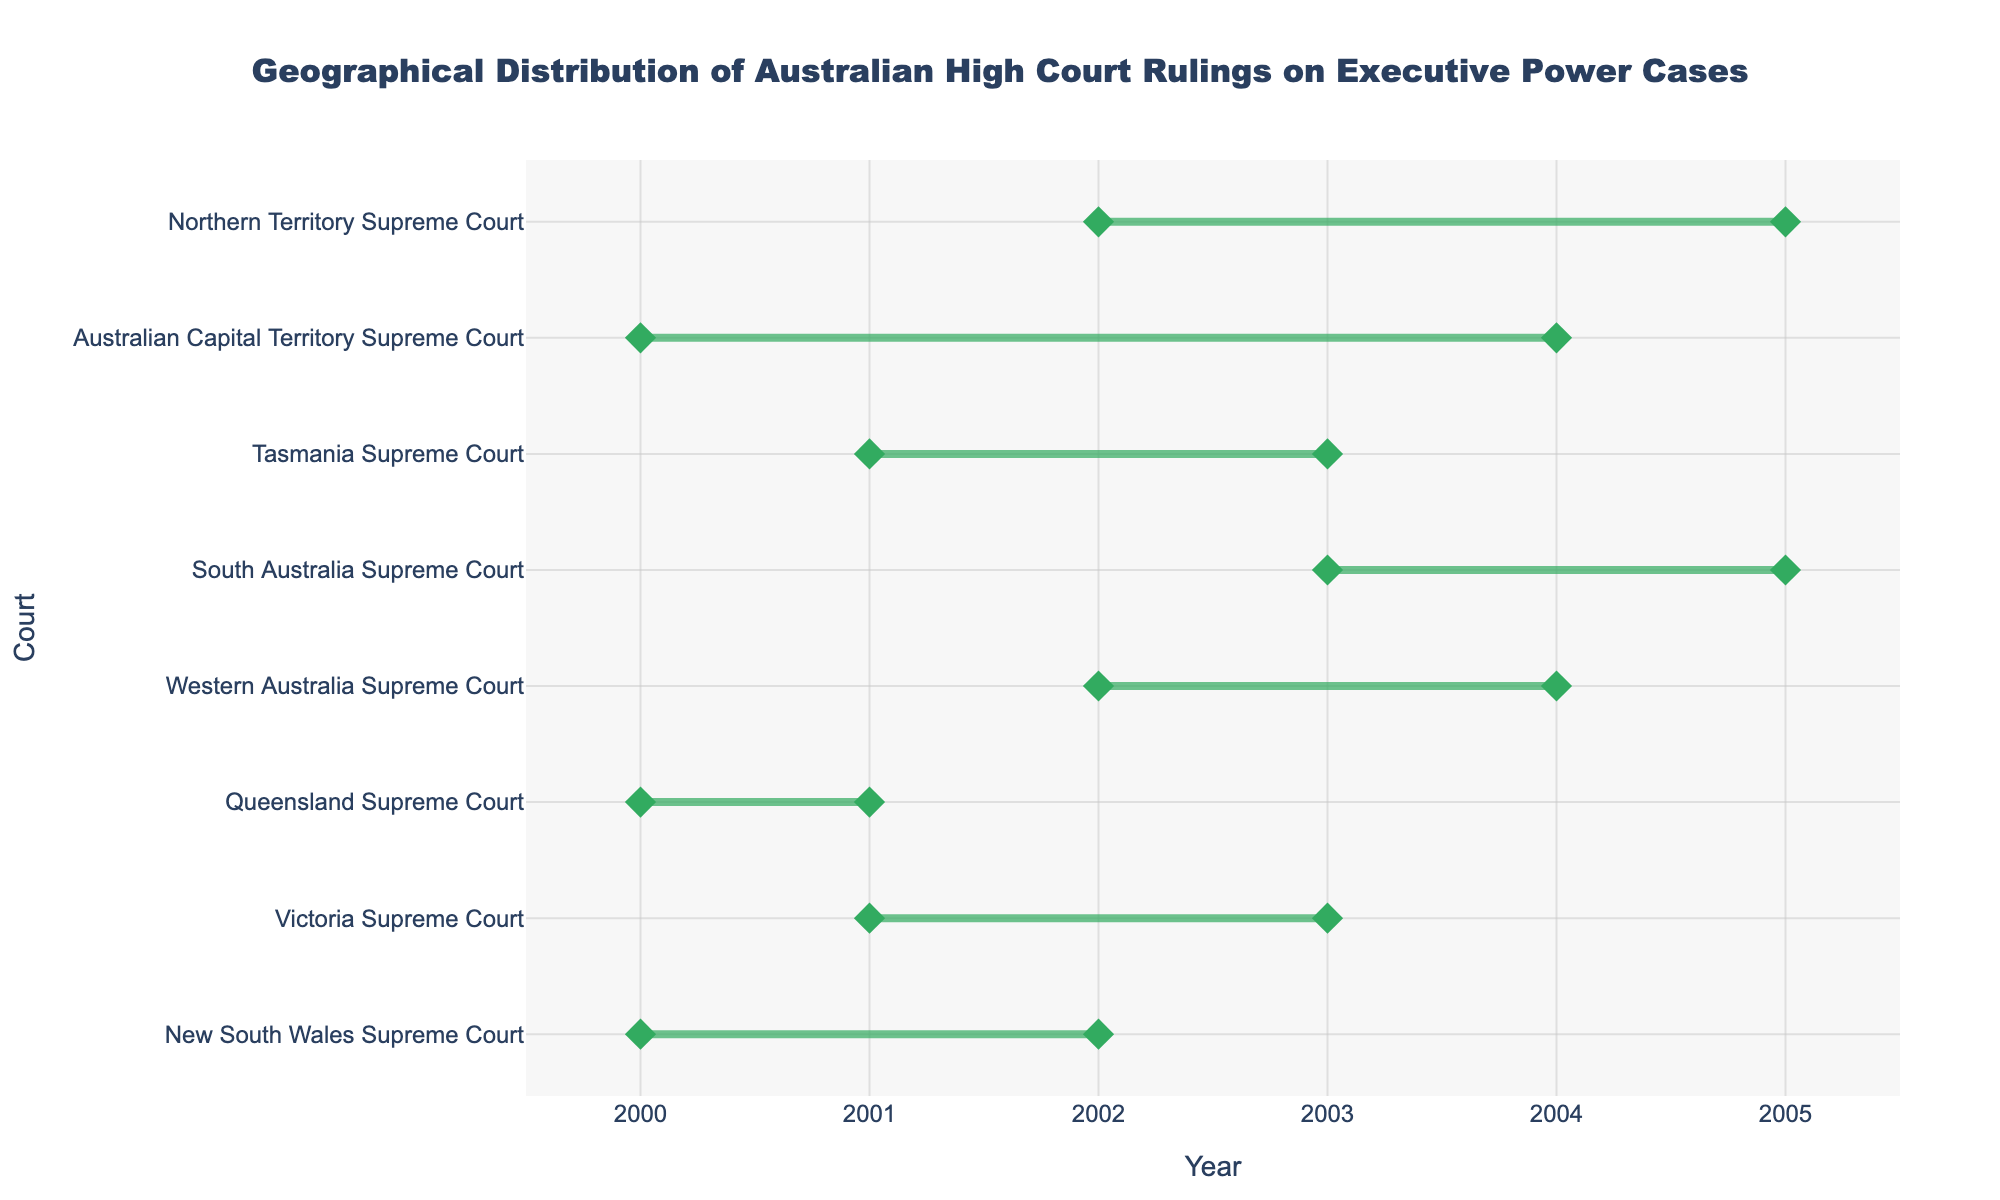What's the title of the plot? The title is usually found at the top of the plot, providing a summary of what the plot represents. The title in this case is "Geographical Distribution of Australian High Court Rulings on Executive Power Cases."
Answer: Geographical Distribution of Australian High Court Rulings on Executive Power Cases Which court has the highest number of rulings? Identify the court with the longest duration in terms of dot markers and observe the text information via hover. The Australian Capital Territory Supreme Court has 8 rulings.
Answer: Australian Capital Territory Supreme Court During which years did the Victoria Supreme Court have rulings on executive power cases? Look at the horizontal line corresponding to the Victoria Supreme Court and read the range on the x-axis. The Victoria Supreme Court rulings span from 2001 to 2003.
Answer: 2001 to 2003 How many rulings were issued by the New South Wales Supreme Court? Find the New South Wales Supreme Court on the y-axis and refer to the text hover information which indicates the number of rulings as 5.
Answer: 5 Which court covered the longest span of years for their cases? Evaluate the length of each line representing the time span of rulings for each court. The Australian Capital Territory Supreme Court covers the longest period, from 2000 to 2004.
Answer: Australian Capital Territory Supreme Court What is the average number of rulings across all courts? Sum the number of rulings for each court (5 + 7 + 4 + 6 + 3 + 2 + 8 + 4) which is 39. There are 8 courts, so the average is 39/8.
Answer: 4.875 How does the number of rulings from the Queensland Supreme Court compare to the Western Australia Supreme Court? Identify the number of rulings for both courts. Queensland Supreme Court has 4, and Western Australia Supreme Court has 6. Queensland Supreme Court has 2 fewer rulings than Western Australia Supreme Court.
Answer: 2 fewer Which court issued executive power rulings between 2003 and 2005? Look for the horizontal lines that overlap with the years 2003 to 2005 on the x-axis. South Australia Supreme Court (2003-2005) and Northern Territory Supreme Court (2002-2005).
Answer: South Australia Supreme Court, Northern Territory Supreme Court What is the median number of rulings across all courts? List the number of rulings (5, 7, 4, 6, 3, 2, 8, 4). Arrange them in ascending order (2, 3, 4, 4, 5, 6, 7, 8). The median of 8 numbers is the average of the 4th and 5th values: (4 + 5) / 2 = 4.5
Answer: 4.5 